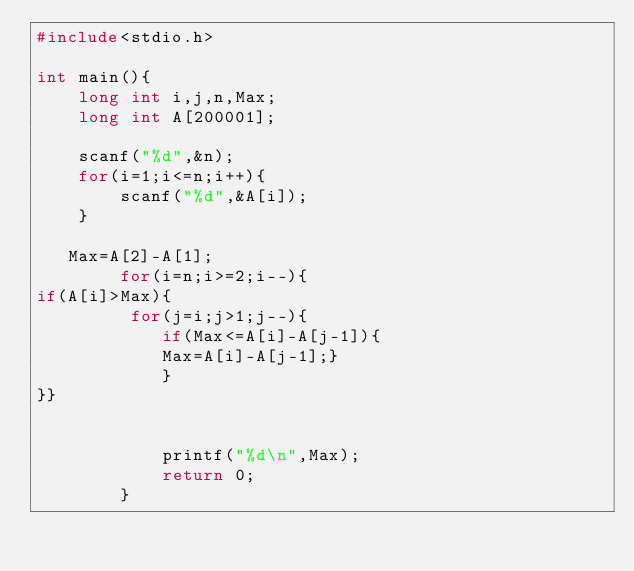<code> <loc_0><loc_0><loc_500><loc_500><_C_>#include<stdio.h>
  
int main(){
    long int i,j,n,Max;
    long int A[200001];
      
    scanf("%d",&n);
    for(i=1;i<=n;i++){
        scanf("%d",&A[i]);
    } 
     
   Max=A[2]-A[1];
        for(i=n;i>=2;i--){
if(A[i]>Max){   
         for(j=i;j>1;j--){
            if(Max<=A[i]-A[j-1]){
            Max=A[i]-A[j-1];}
            }
}}

        
            printf("%d\n",Max);
            return 0;
        }
	</code> 